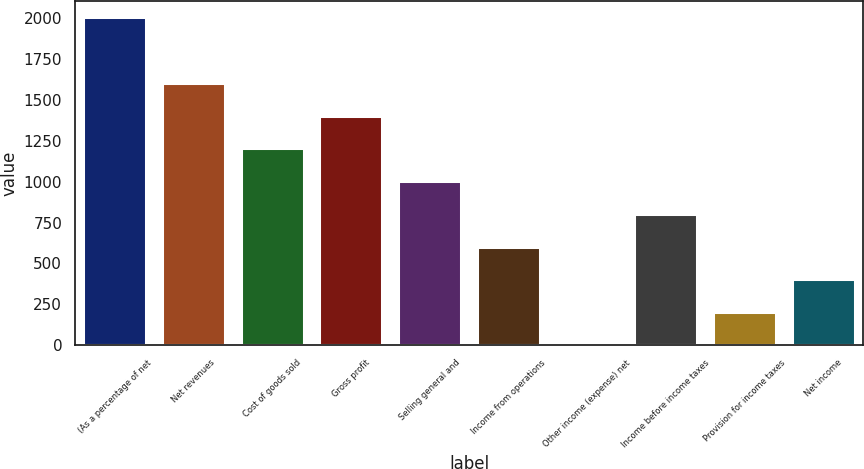<chart> <loc_0><loc_0><loc_500><loc_500><bar_chart><fcel>(As a percentage of net<fcel>Net revenues<fcel>Cost of goods sold<fcel>Gross profit<fcel>Selling general and<fcel>Income from operations<fcel>Other income (expense) net<fcel>Income before income taxes<fcel>Provision for income taxes<fcel>Net income<nl><fcel>2007<fcel>1605.7<fcel>1204.4<fcel>1405.05<fcel>1003.75<fcel>602.45<fcel>0.5<fcel>803.1<fcel>201.15<fcel>401.8<nl></chart> 